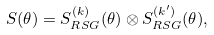Convert formula to latex. <formula><loc_0><loc_0><loc_500><loc_500>S ( \theta ) = S ^ { ( k ) } _ { R S G } ( \theta ) \otimes S ^ { ( k ^ { \prime } ) } _ { R S G } ( \theta ) ,</formula> 